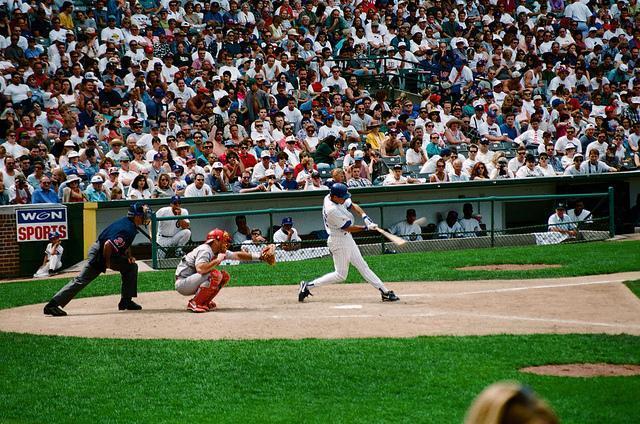How many people are in the photo?
Give a very brief answer. 3. 